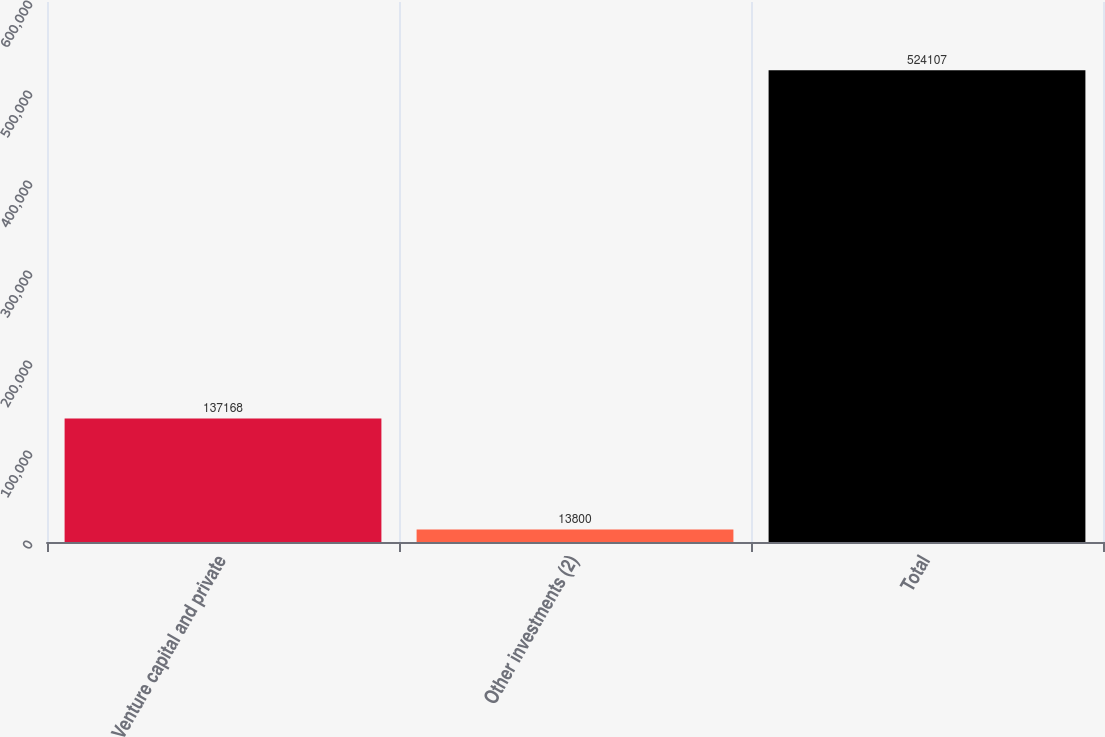Convert chart. <chart><loc_0><loc_0><loc_500><loc_500><bar_chart><fcel>Venture capital and private<fcel>Other investments (2)<fcel>Total<nl><fcel>137168<fcel>13800<fcel>524107<nl></chart> 